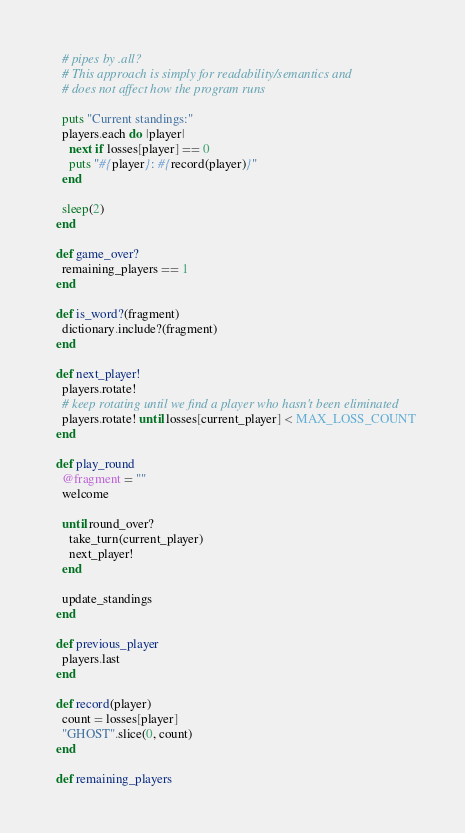Convert code to text. <code><loc_0><loc_0><loc_500><loc_500><_Ruby_>    # pipes by .all?
    # This approach is simply for readability/semantics and
    # does not affect how the program runs

    puts "Current standings:"
    players.each do |player|
      next if losses[player] == 0
      puts "#{player}: #{record(player)}"
    end

    sleep(2)
  end

  def game_over?
    remaining_players == 1
  end

  def is_word?(fragment)
    dictionary.include?(fragment)
  end

  def next_player!
    players.rotate!
    # keep rotating until we find a player who hasn't been eliminated
    players.rotate! until losses[current_player] < MAX_LOSS_COUNT
  end

  def play_round
    @fragment = ""
    welcome

    until round_over?
      take_turn(current_player)
      next_player!
    end

    update_standings
  end

  def previous_player
    players.last
  end

  def record(player)
    count = losses[player]
    "GHOST".slice(0, count)
  end

  def remaining_players</code> 